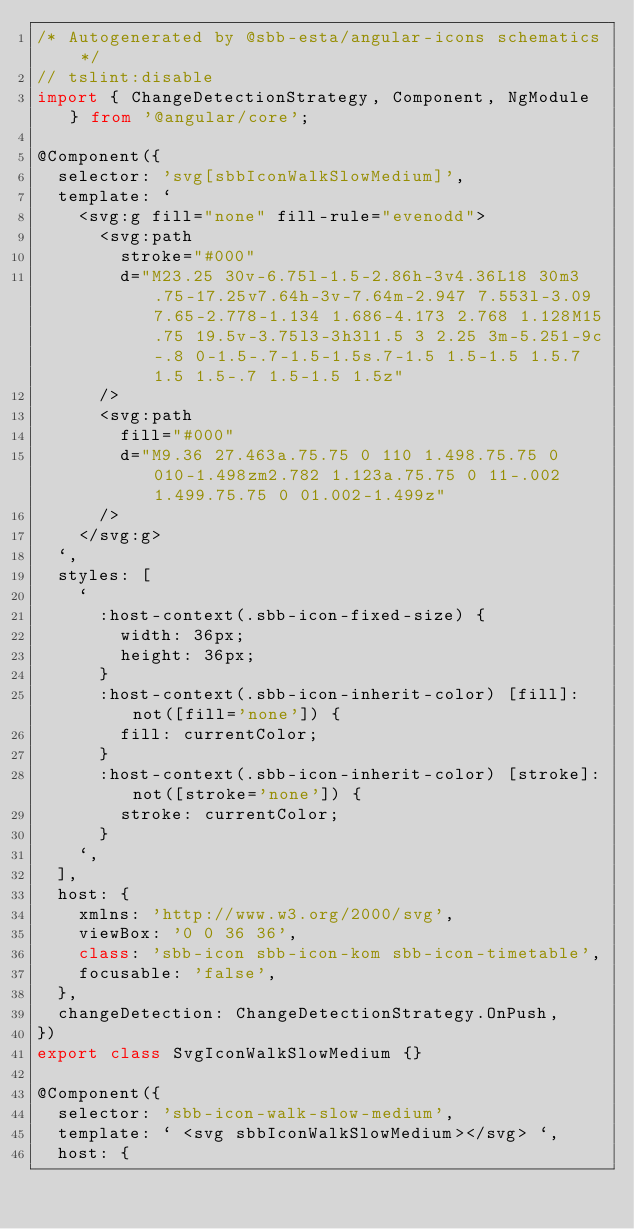Convert code to text. <code><loc_0><loc_0><loc_500><loc_500><_TypeScript_>/* Autogenerated by @sbb-esta/angular-icons schematics */
// tslint:disable
import { ChangeDetectionStrategy, Component, NgModule } from '@angular/core';

@Component({
  selector: 'svg[sbbIconWalkSlowMedium]',
  template: `
    <svg:g fill="none" fill-rule="evenodd">
      <svg:path
        stroke="#000"
        d="M23.25 30v-6.75l-1.5-2.86h-3v4.36L18 30m3.75-17.25v7.64h-3v-7.64m-2.947 7.553l-3.09 7.65-2.778-1.134 1.686-4.173 2.768 1.128M15.75 19.5v-3.75l3-3h3l1.5 3 2.25 3m-5.251-9c-.8 0-1.5-.7-1.5-1.5s.7-1.5 1.5-1.5 1.5.7 1.5 1.5-.7 1.5-1.5 1.5z"
      />
      <svg:path
        fill="#000"
        d="M9.36 27.463a.75.75 0 110 1.498.75.75 0 010-1.498zm2.782 1.123a.75.75 0 11-.002 1.499.75.75 0 01.002-1.499z"
      />
    </svg:g>
  `,
  styles: [
    `
      :host-context(.sbb-icon-fixed-size) {
        width: 36px;
        height: 36px;
      }
      :host-context(.sbb-icon-inherit-color) [fill]:not([fill='none']) {
        fill: currentColor;
      }
      :host-context(.sbb-icon-inherit-color) [stroke]:not([stroke='none']) {
        stroke: currentColor;
      }
    `,
  ],
  host: {
    xmlns: 'http://www.w3.org/2000/svg',
    viewBox: '0 0 36 36',
    class: 'sbb-icon sbb-icon-kom sbb-icon-timetable',
    focusable: 'false',
  },
  changeDetection: ChangeDetectionStrategy.OnPush,
})
export class SvgIconWalkSlowMedium {}

@Component({
  selector: 'sbb-icon-walk-slow-medium',
  template: ` <svg sbbIconWalkSlowMedium></svg> `,
  host: {</code> 